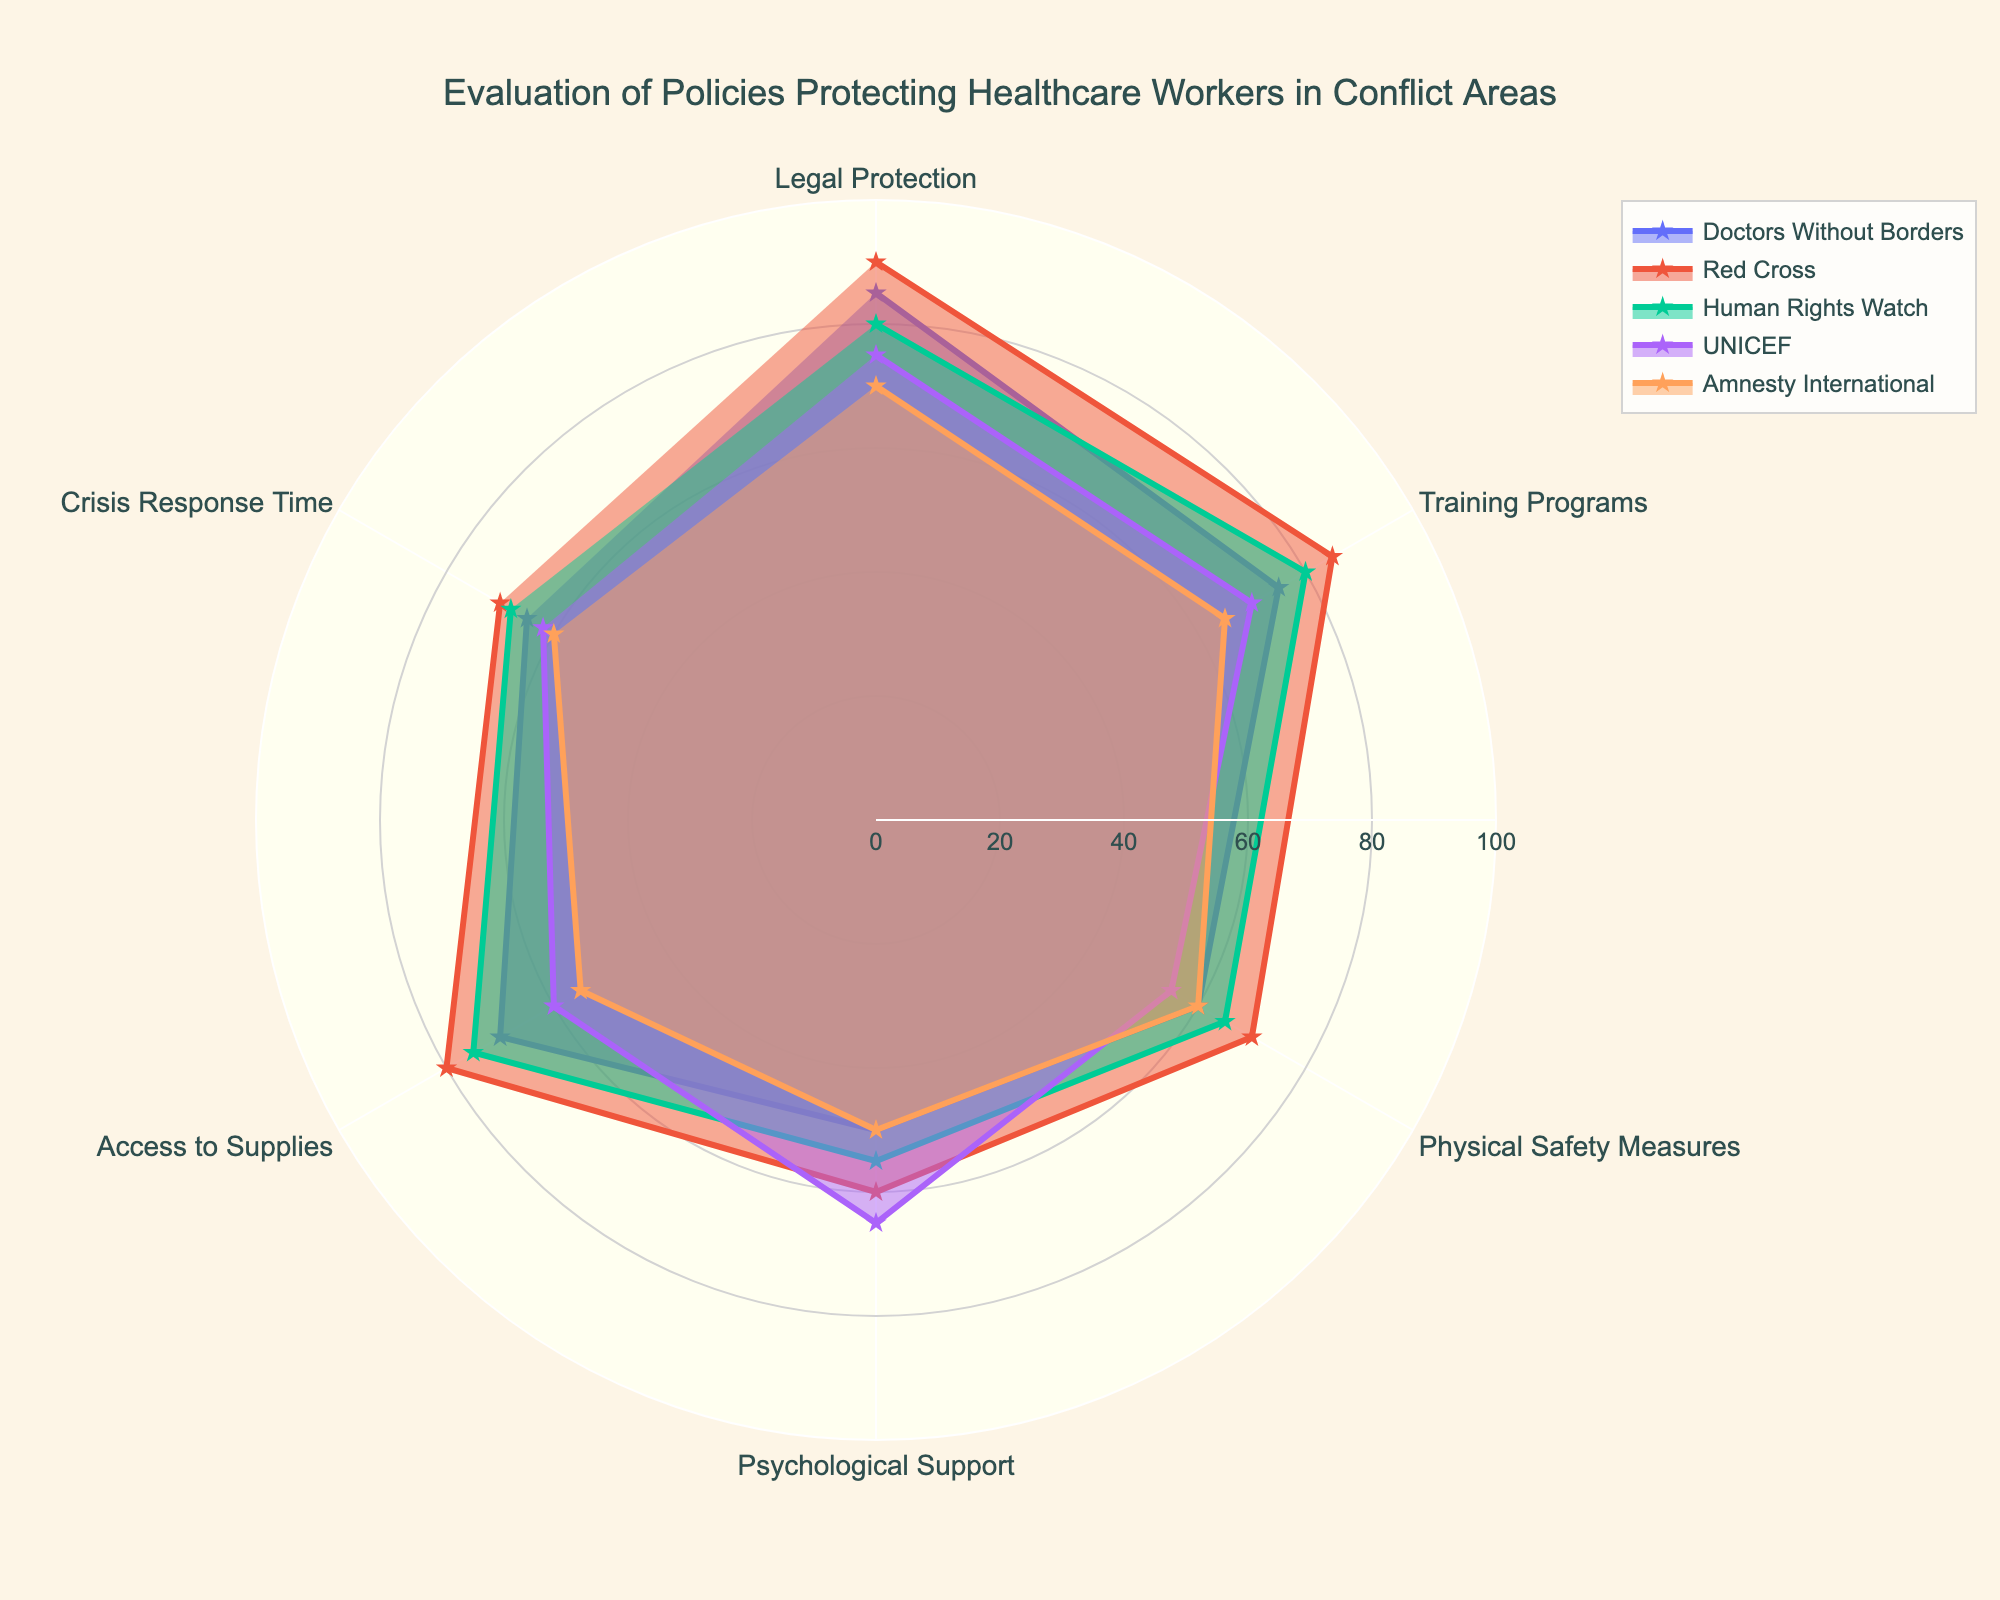What's the title of the figure? The title is usually placed at the top center of a chart for clarity. Here, the title is "Evaluation of Policies Protecting Healthcare Workers in Conflict Areas," clearly noted at the top.
Answer: Evaluation of Policies Protecting Healthcare Workers in Conflict Areas Which organization provides the highest rating for Legal Protection? We need to look at the Legal Protection category and compare the ratings of all organizations. The highest value is 90, provided by the Red Cross.
Answer: Red Cross What policy area has the lowest rating from Amnesty International? Check the values of all policy areas under Amnesty International, and the lowest value is 50 in the Psychological Support category.
Answer: Psychological Support How many policy areas are evaluated in the figure? There are several categories in the radar chart, each representing a policy area. Counting these categories, we find there are six policy areas.
Answer: Six What's the average rating given by Doctors Without Borders for all policy areas? Sum all the ratings given by Doctors Without Borders (85+75+60+50+70+65) to get 405. Dividing by the number of areas (6), we get 405/6 = 67.5
Answer: 67.5 Which policy area shows the most significant difference between the highest and lowest ratings? First, find the difference for each policy area: 
Legal Protection (90-70=20), Training Programs (85-65=20), Physical Safety Measures (70-55=15), Psychological Support (65-50=15), Access to Supplies (80-55=25), Crisis Response Time (70-60=10). The highest difference is in Access to Supplies with 25 points.
Answer: Access to Supplies Which organization provides the most consistent ratings across all policy areas? Calculate the range of values (difference between the highest and lowest ratings) for each organization:
Doctors Without Borders (85-50=35), Red Cross (90-60=30), Human Rights Watch (80-55=25), UNICEF (75-55=20), Amnesty International (70-50=20). The smallest range is 20, shared by UNICEF and Amnesty International.
Answer: UNICEF and Amnesty International What is the median rating for Physical Safety Measures across all organizations? List the values for Physical Safety Measures (60, 70, 65, 55, 60). Arrange in order: 55, 60, 60, 65, 70. The median (middle value in ordered list) is 60.
Answer: 60 Comparing Training Programs and Crisis Response Time, which policy area has higher overall ratings? Calculate the average for both: 
Training Programs (75+85+80+70+65=375; 375/5=75), Crisis Response Time (65+70+68+62+60=325; 325/5=65). Training Programs have a higher average rating of 75 compared to 65 for Crisis Response Time.
Answer: Training Programs What is the total rating for the Access to Supplies policy area from all five organizations? Add the values for Access to Supplies from all organizations (70+80+75+60+55). The sum is 340.
Answer: 340 